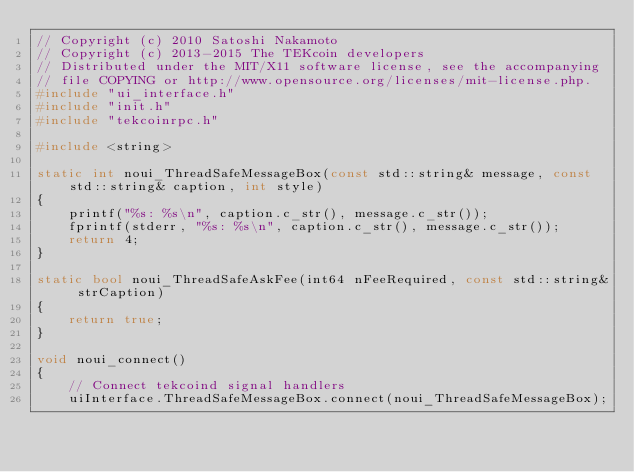Convert code to text. <code><loc_0><loc_0><loc_500><loc_500><_C++_>// Copyright (c) 2010 Satoshi Nakamoto
// Copyright (c) 2013-2015 The TEKcoin developers
// Distributed under the MIT/X11 software license, see the accompanying
// file COPYING or http://www.opensource.org/licenses/mit-license.php.
#include "ui_interface.h"
#include "init.h"
#include "tekcoinrpc.h"

#include <string>

static int noui_ThreadSafeMessageBox(const std::string& message, const std::string& caption, int style)
{
    printf("%s: %s\n", caption.c_str(), message.c_str());
    fprintf(stderr, "%s: %s\n", caption.c_str(), message.c_str());
    return 4;
}

static bool noui_ThreadSafeAskFee(int64 nFeeRequired, const std::string& strCaption)
{
    return true;
}

void noui_connect()
{
    // Connect tekcoind signal handlers
    uiInterface.ThreadSafeMessageBox.connect(noui_ThreadSafeMessageBox);</code> 